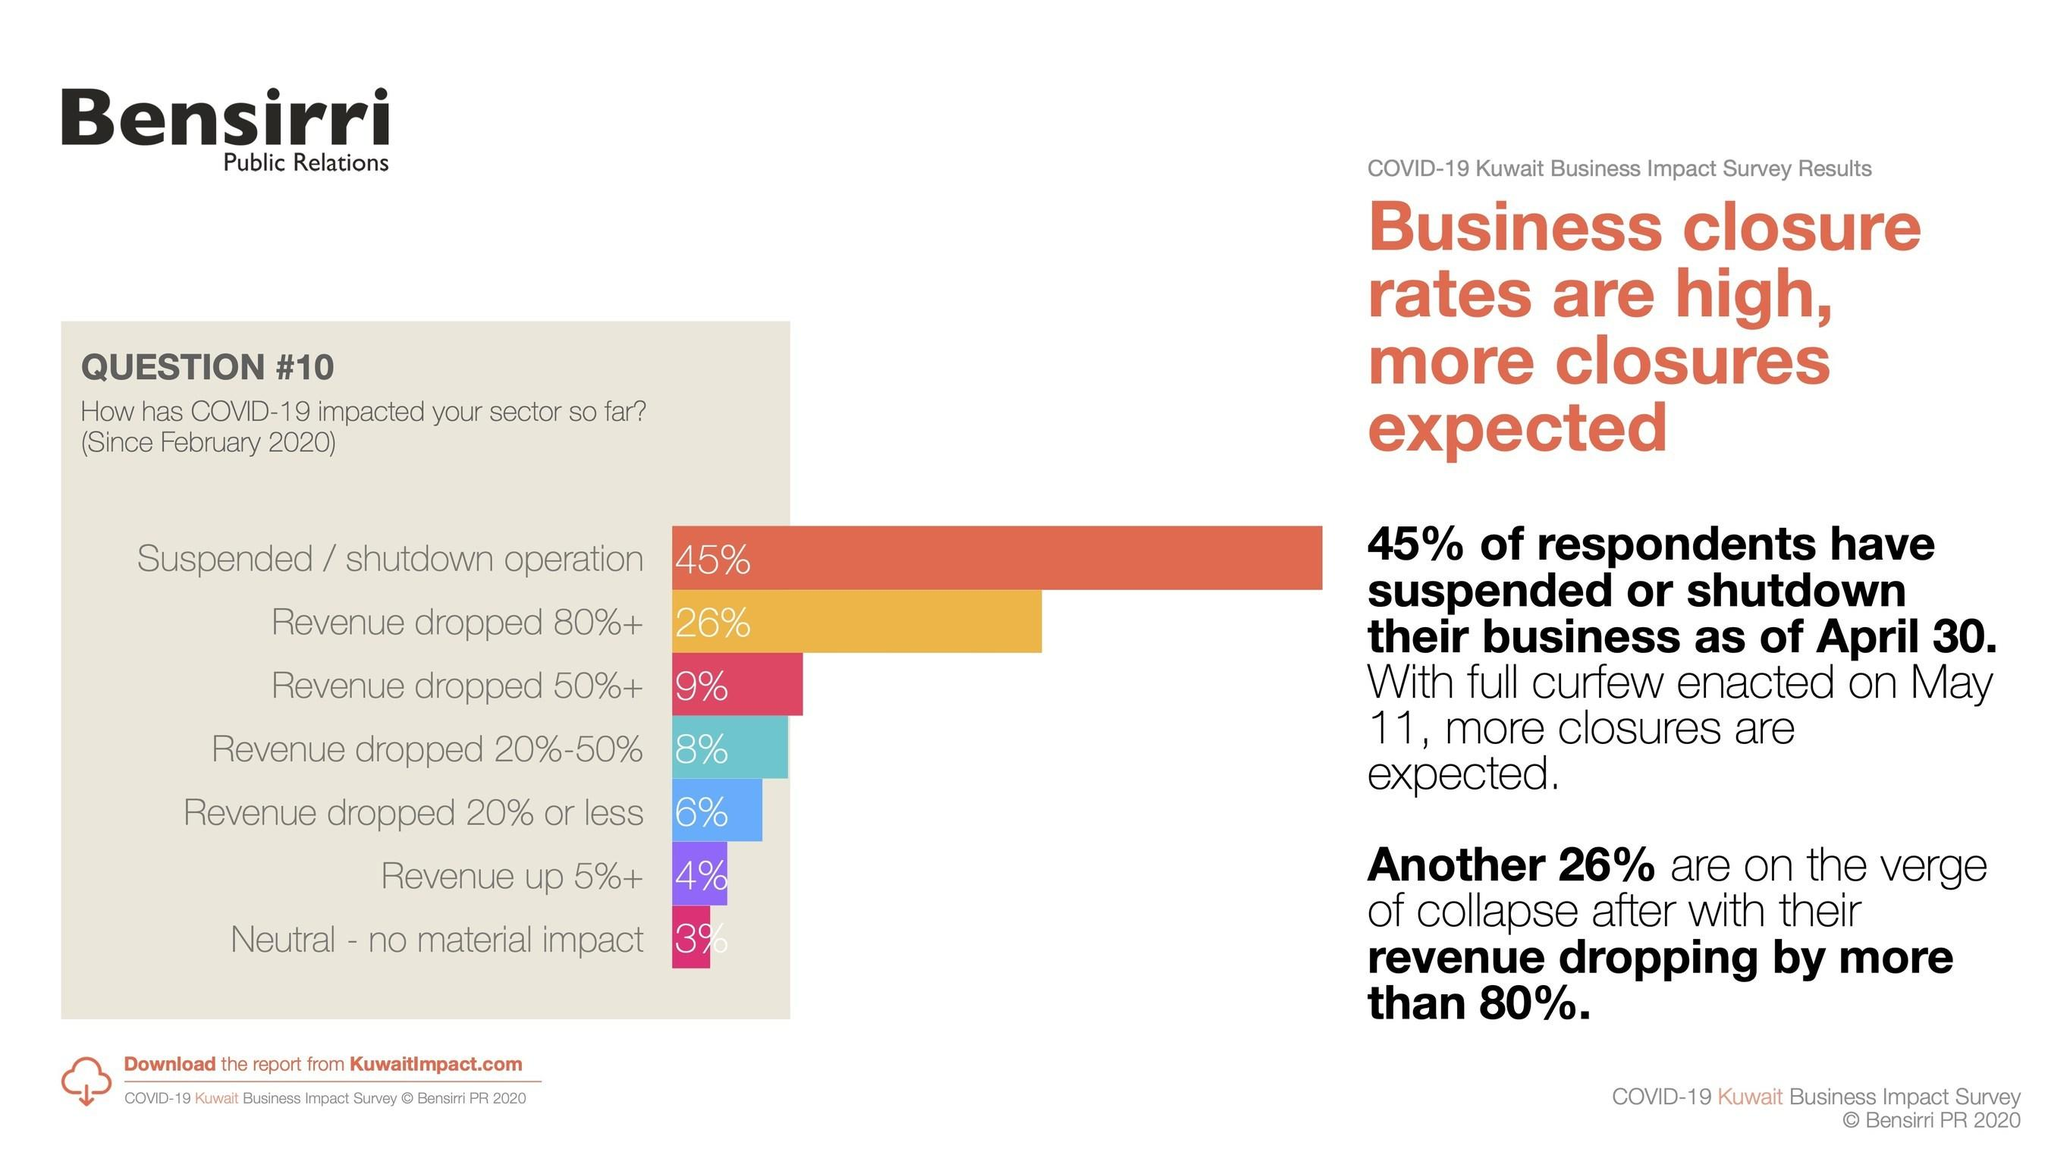Mention a couple of crucial points in this snapshot. According to the given data, approximately 14% of businesses have experienced a decrease in revenue of 50% or less. A small percentage of businesses, approximately 7%, have reported that their revenue has not decreased. 